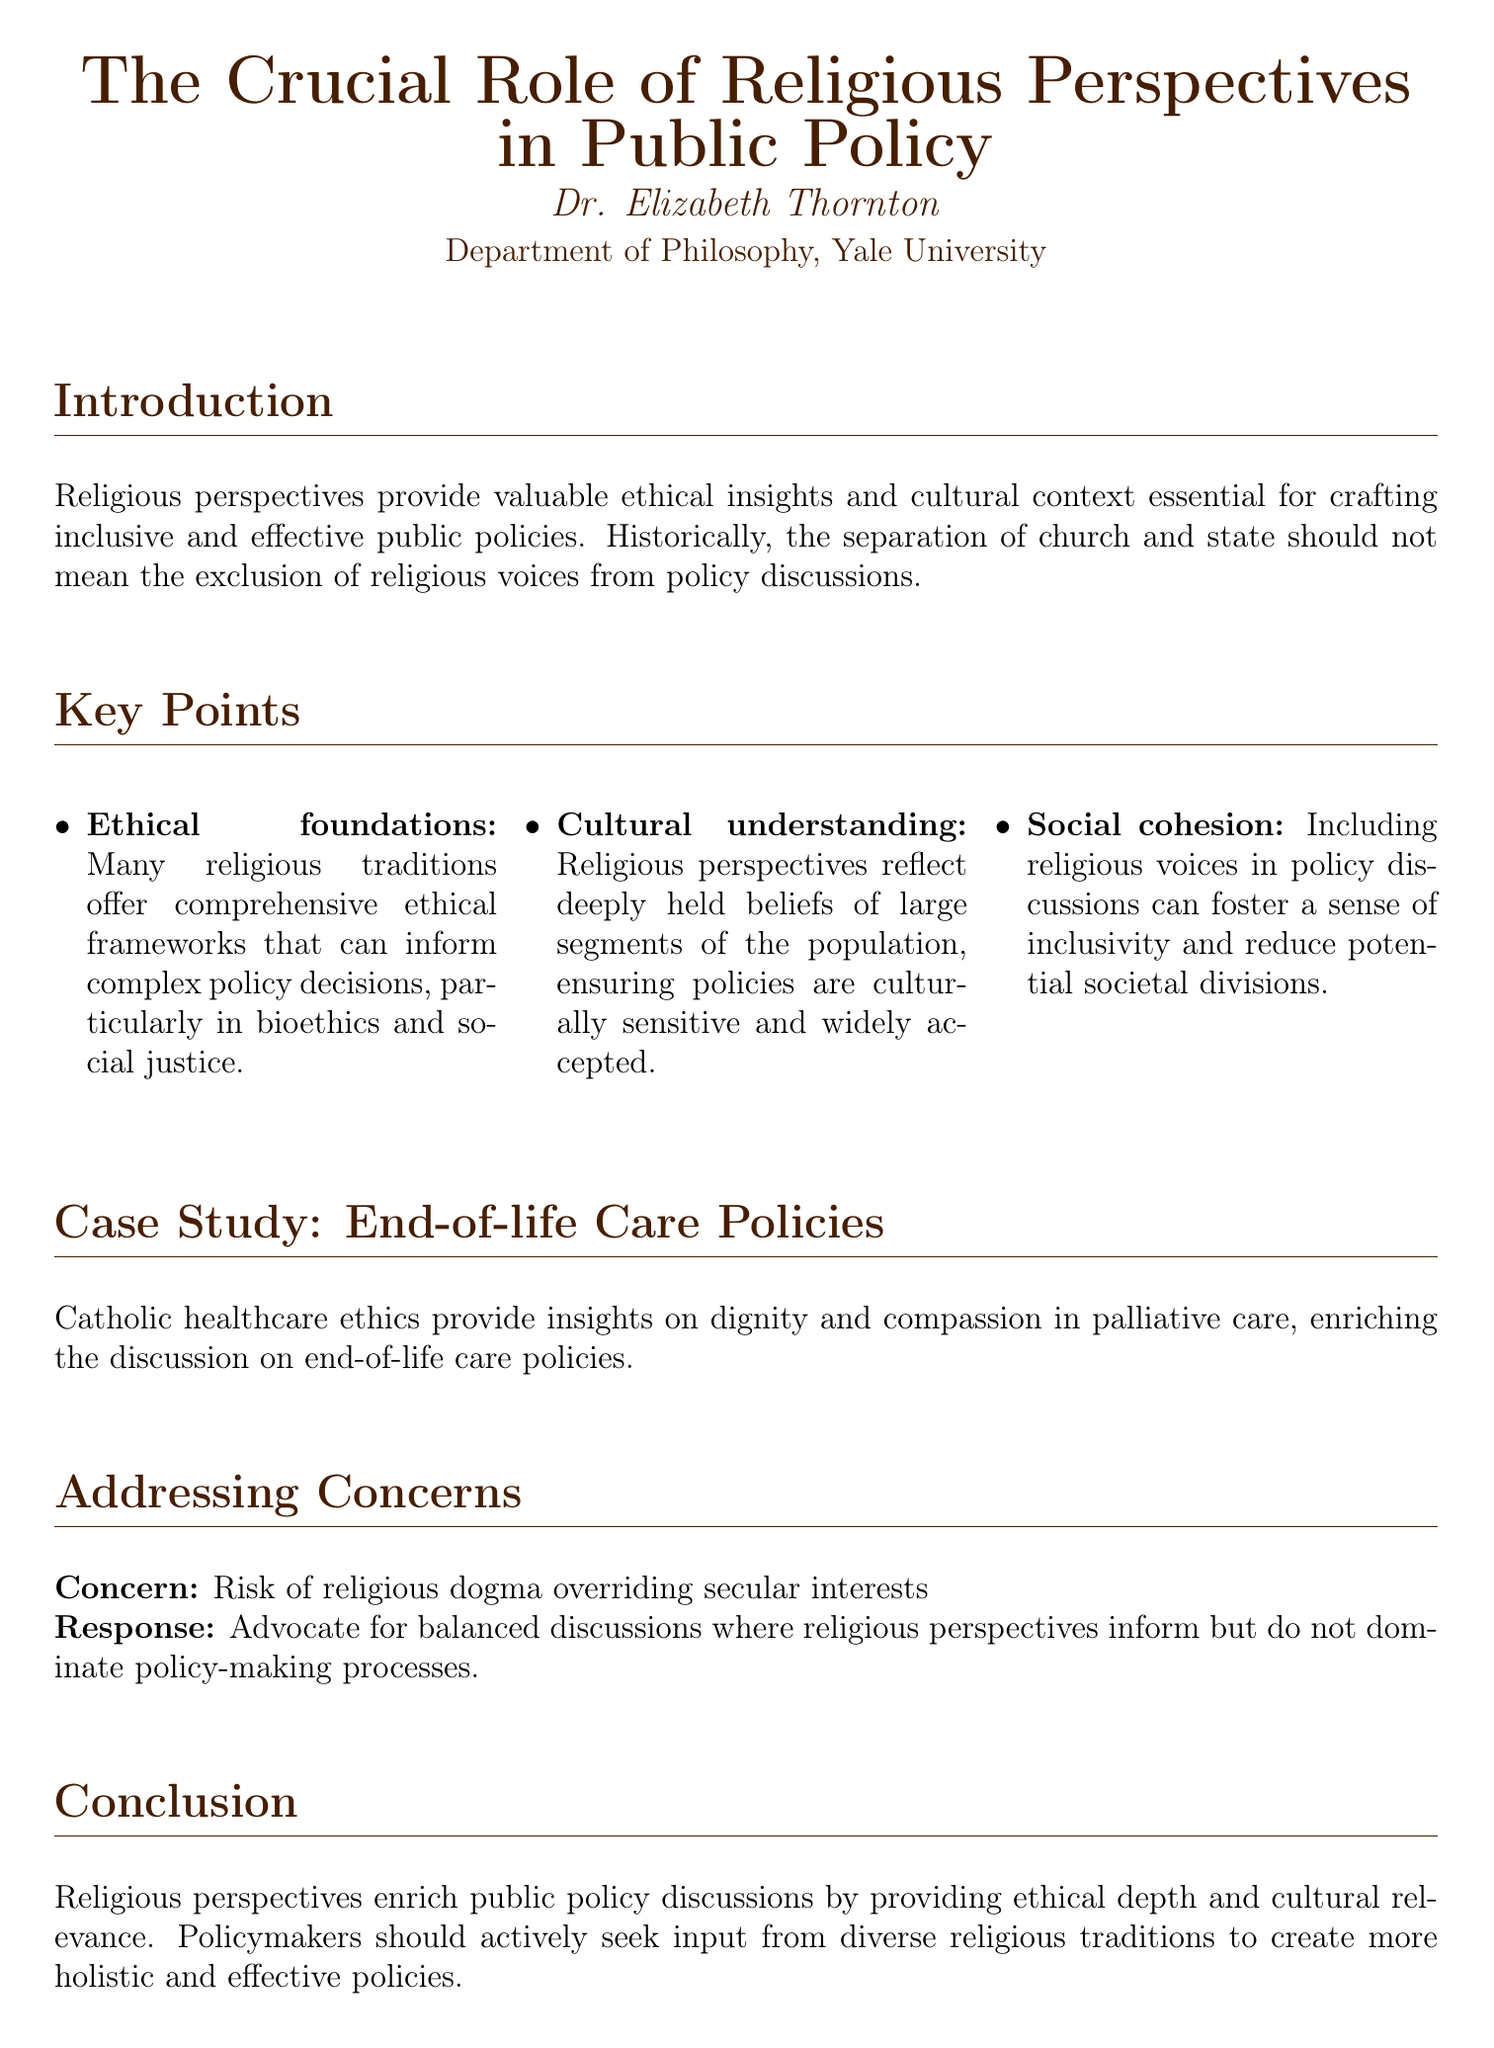What is the title of the fax? The title is prominently displayed at the top of the document, stating the central theme of the piece.
Answer: The Crucial Role of Religious Perspectives in Public Policy Who is the author of the fax? The author's name appears below the title, indicating who contributed to the content of the document.
Answer: Dr. Elizabeth Thornton Which department is Dr. Elizabeth Thornton associated with? The author's affiliation is explicitly mentioned under their name, showcasing their academic background.
Answer: Department of Philosophy, Yale University How many key points are listed in the document? The document lists several key points, which are enumerated in a specific section.
Answer: Three What ethical area is highlighted in the case study mentioned? The case study within the document focuses on a specific aspect of healthcare to illustrate the main argument.
Answer: End-of-life Care Policies What concern is addressed in the document? The document mentions a particular concern regarding the implications of religious influence on policy-making.
Answer: Risk of religious dogma overriding secular interests What is the proposed response to the concern mentioned? The document provides a specific response to the mentioned concern, outlining the desired approach to discussions.
Answer: Advocate for balanced discussions What does including religious voices in policy discussions foster, according to the document? The document describes a positive outcome associated with engaging religious perspectives in policymaking.
Answer: Social cohesion What aspect of care does Catholic healthcare ethics provide insights on? The document references a specific ethical viewpoint that informs discussions about healthcare policies.
Answer: Dignity and compassion 